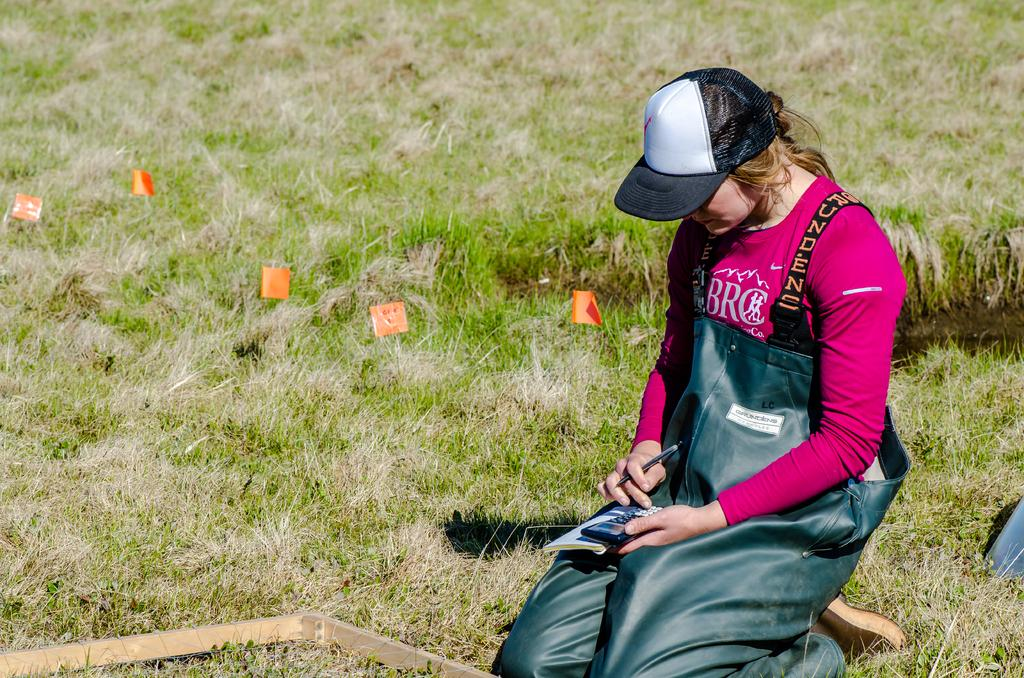Who is the main subject in the image? There is a lady in the image. What is the lady wearing on her head? The lady is wearing a cap. What objects is the lady holding in her hands? The lady is holding a book, a calculator, and a pen. What position is the lady in? The lady is in a kneel position. What type of surface is visible on the ground? There is grass on the ground. What additional items can be seen on the ground? There are orange peppers on the ground. How many friends are visible in the image? There are no friends visible in the image; it only features a lady. What type of acoustics can be heard in the image? There is no sound or acoustics present in the image, as it is a still photograph. 